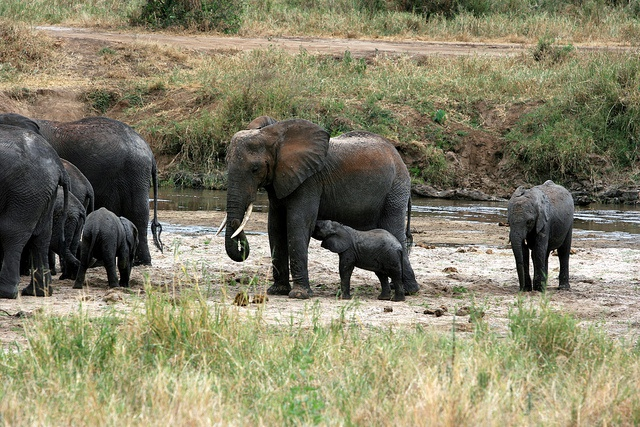Describe the objects in this image and their specific colors. I can see elephant in tan, black, gray, and darkgray tones, elephant in tan, black, gray, and darkgray tones, elephant in tan, black, gray, and darkgray tones, elephant in tan, black, gray, darkgray, and lightgray tones, and elephant in tan, black, gray, darkgray, and lightgray tones in this image. 